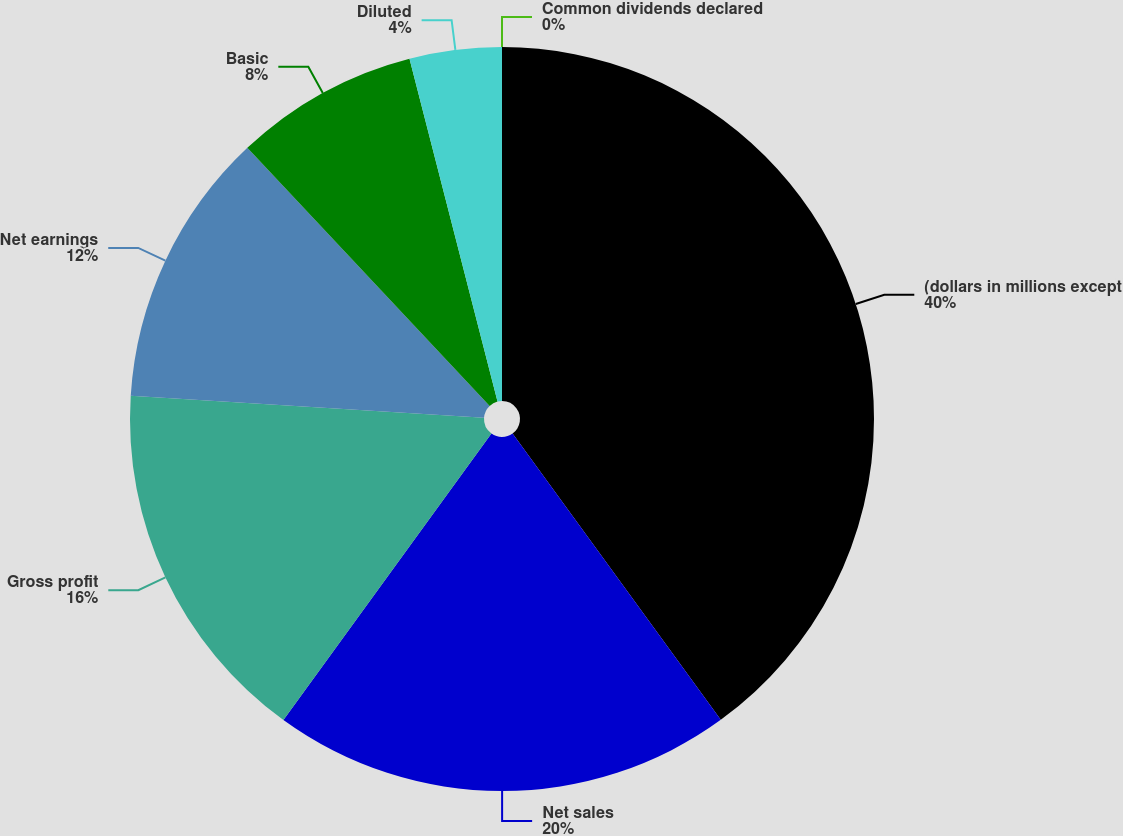Convert chart to OTSL. <chart><loc_0><loc_0><loc_500><loc_500><pie_chart><fcel>(dollars in millions except<fcel>Net sales<fcel>Gross profit<fcel>Net earnings<fcel>Basic<fcel>Diluted<fcel>Common dividends declared<nl><fcel>39.99%<fcel>20.0%<fcel>16.0%<fcel>12.0%<fcel>8.0%<fcel>4.0%<fcel>0.0%<nl></chart> 